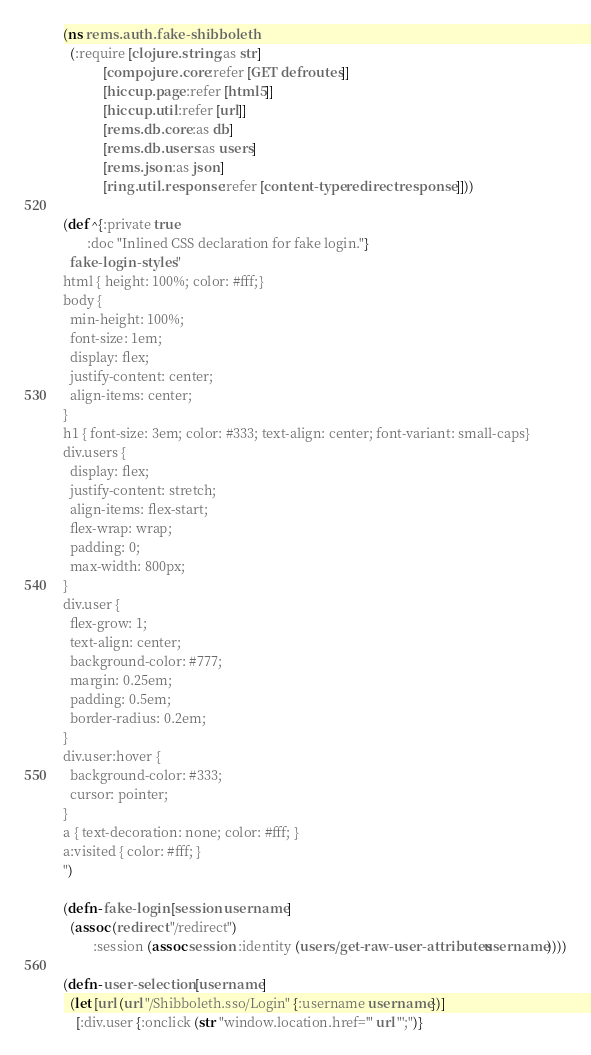<code> <loc_0><loc_0><loc_500><loc_500><_Clojure_>(ns rems.auth.fake-shibboleth
  (:require [clojure.string :as str]
            [compojure.core :refer [GET defroutes]]
            [hiccup.page :refer [html5]]
            [hiccup.util :refer [url]]
            [rems.db.core :as db]
            [rems.db.users :as users]
            [rems.json :as json]
            [ring.util.response :refer [content-type redirect response]]))

(def ^{:private true
       :doc "Inlined CSS declaration for fake login."}
  fake-login-styles "
html { height: 100%; color: #fff;}
body {
  min-height: 100%;
  font-size: 1em;
  display: flex;
  justify-content: center;
  align-items: center;
}
h1 { font-size: 3em; color: #333; text-align: center; font-variant: small-caps}
div.users {
  display: flex;
  justify-content: stretch;
  align-items: flex-start;
  flex-wrap: wrap;
  padding: 0;
  max-width: 800px;
}
div.user {
  flex-grow: 1;
  text-align: center;
  background-color: #777;
  margin: 0.25em;
  padding: 0.5em;
  border-radius: 0.2em;
}
div.user:hover {
  background-color: #333;
  cursor: pointer;
}
a { text-decoration: none; color: #fff; }
a:visited { color: #fff; }
")

(defn- fake-login [session username]
  (assoc (redirect "/redirect")
         :session (assoc session :identity (users/get-raw-user-attributes username))))

(defn- user-selection [username]
  (let [url (url "/Shibboleth.sso/Login" {:username username})]
    [:div.user {:onclick (str "window.location.href='" url "';")}</code> 